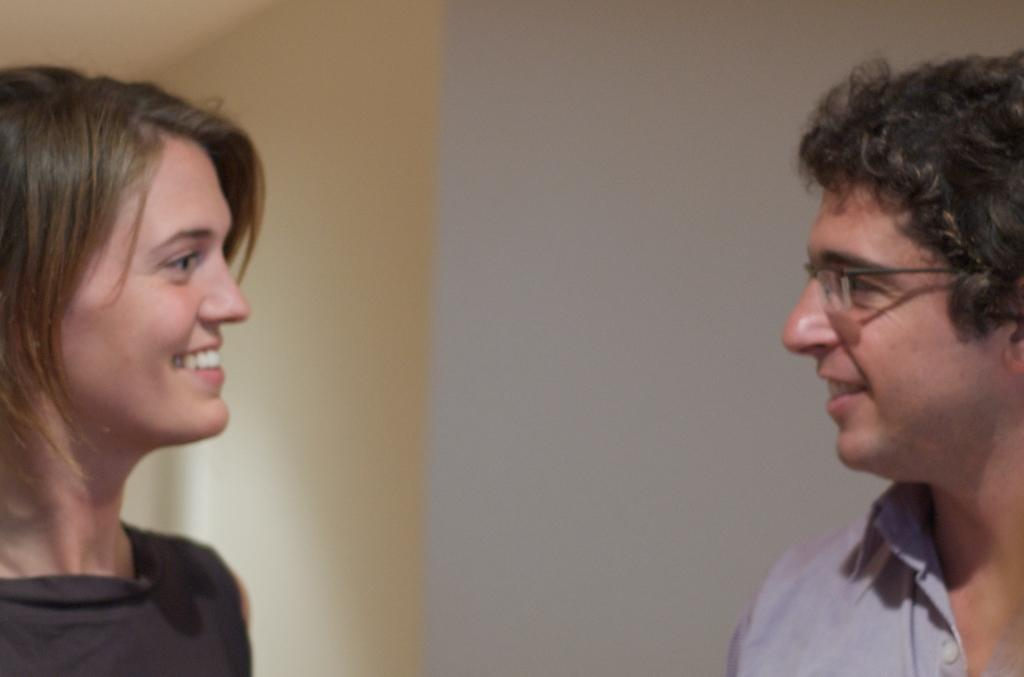Who is present in the image? There is a man and a woman in the image. What are the man and woman doing in the image? The man and woman are looking at each other and smiling. What can be seen in the background of the image? There is a wall in the background of the image. What time of day is it in the image, and is it a quiet or noisy environment? The time of day and the noise level cannot be determined from the image, as there is no information about the time or the environment's sound level. 